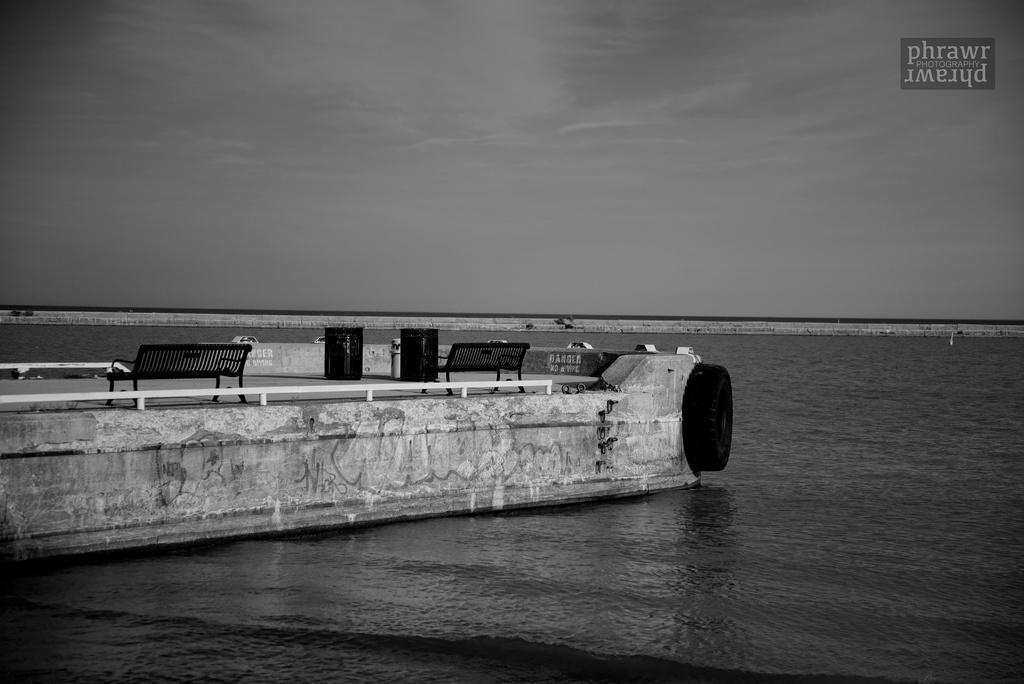Can you describe this image briefly? In this image there is a river, beside the river there is a tire on the concrete platform and there are two trash cans and two benches on it, in the background of the image there is a concrete fence, at the top right of the image there is a logo and clouds in the sky. 